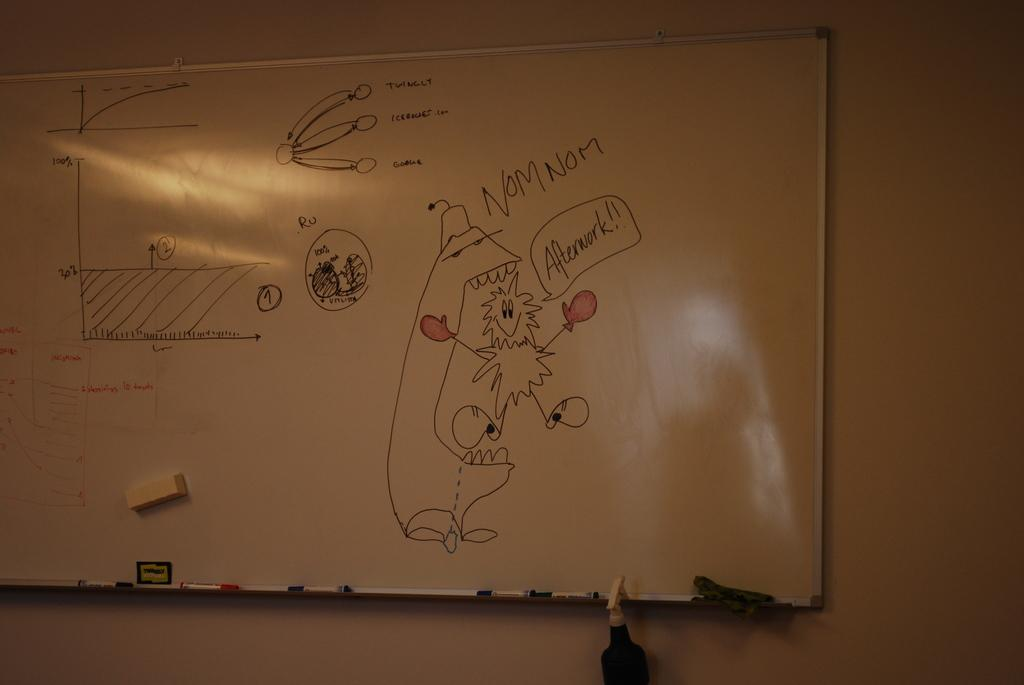<image>
Render a clear and concise summary of the photo. A dry erase board has a graph and a picture of a happy, fuzzy being saying, "Afterwork!" and labeled with the saying, "NOM NOM." 